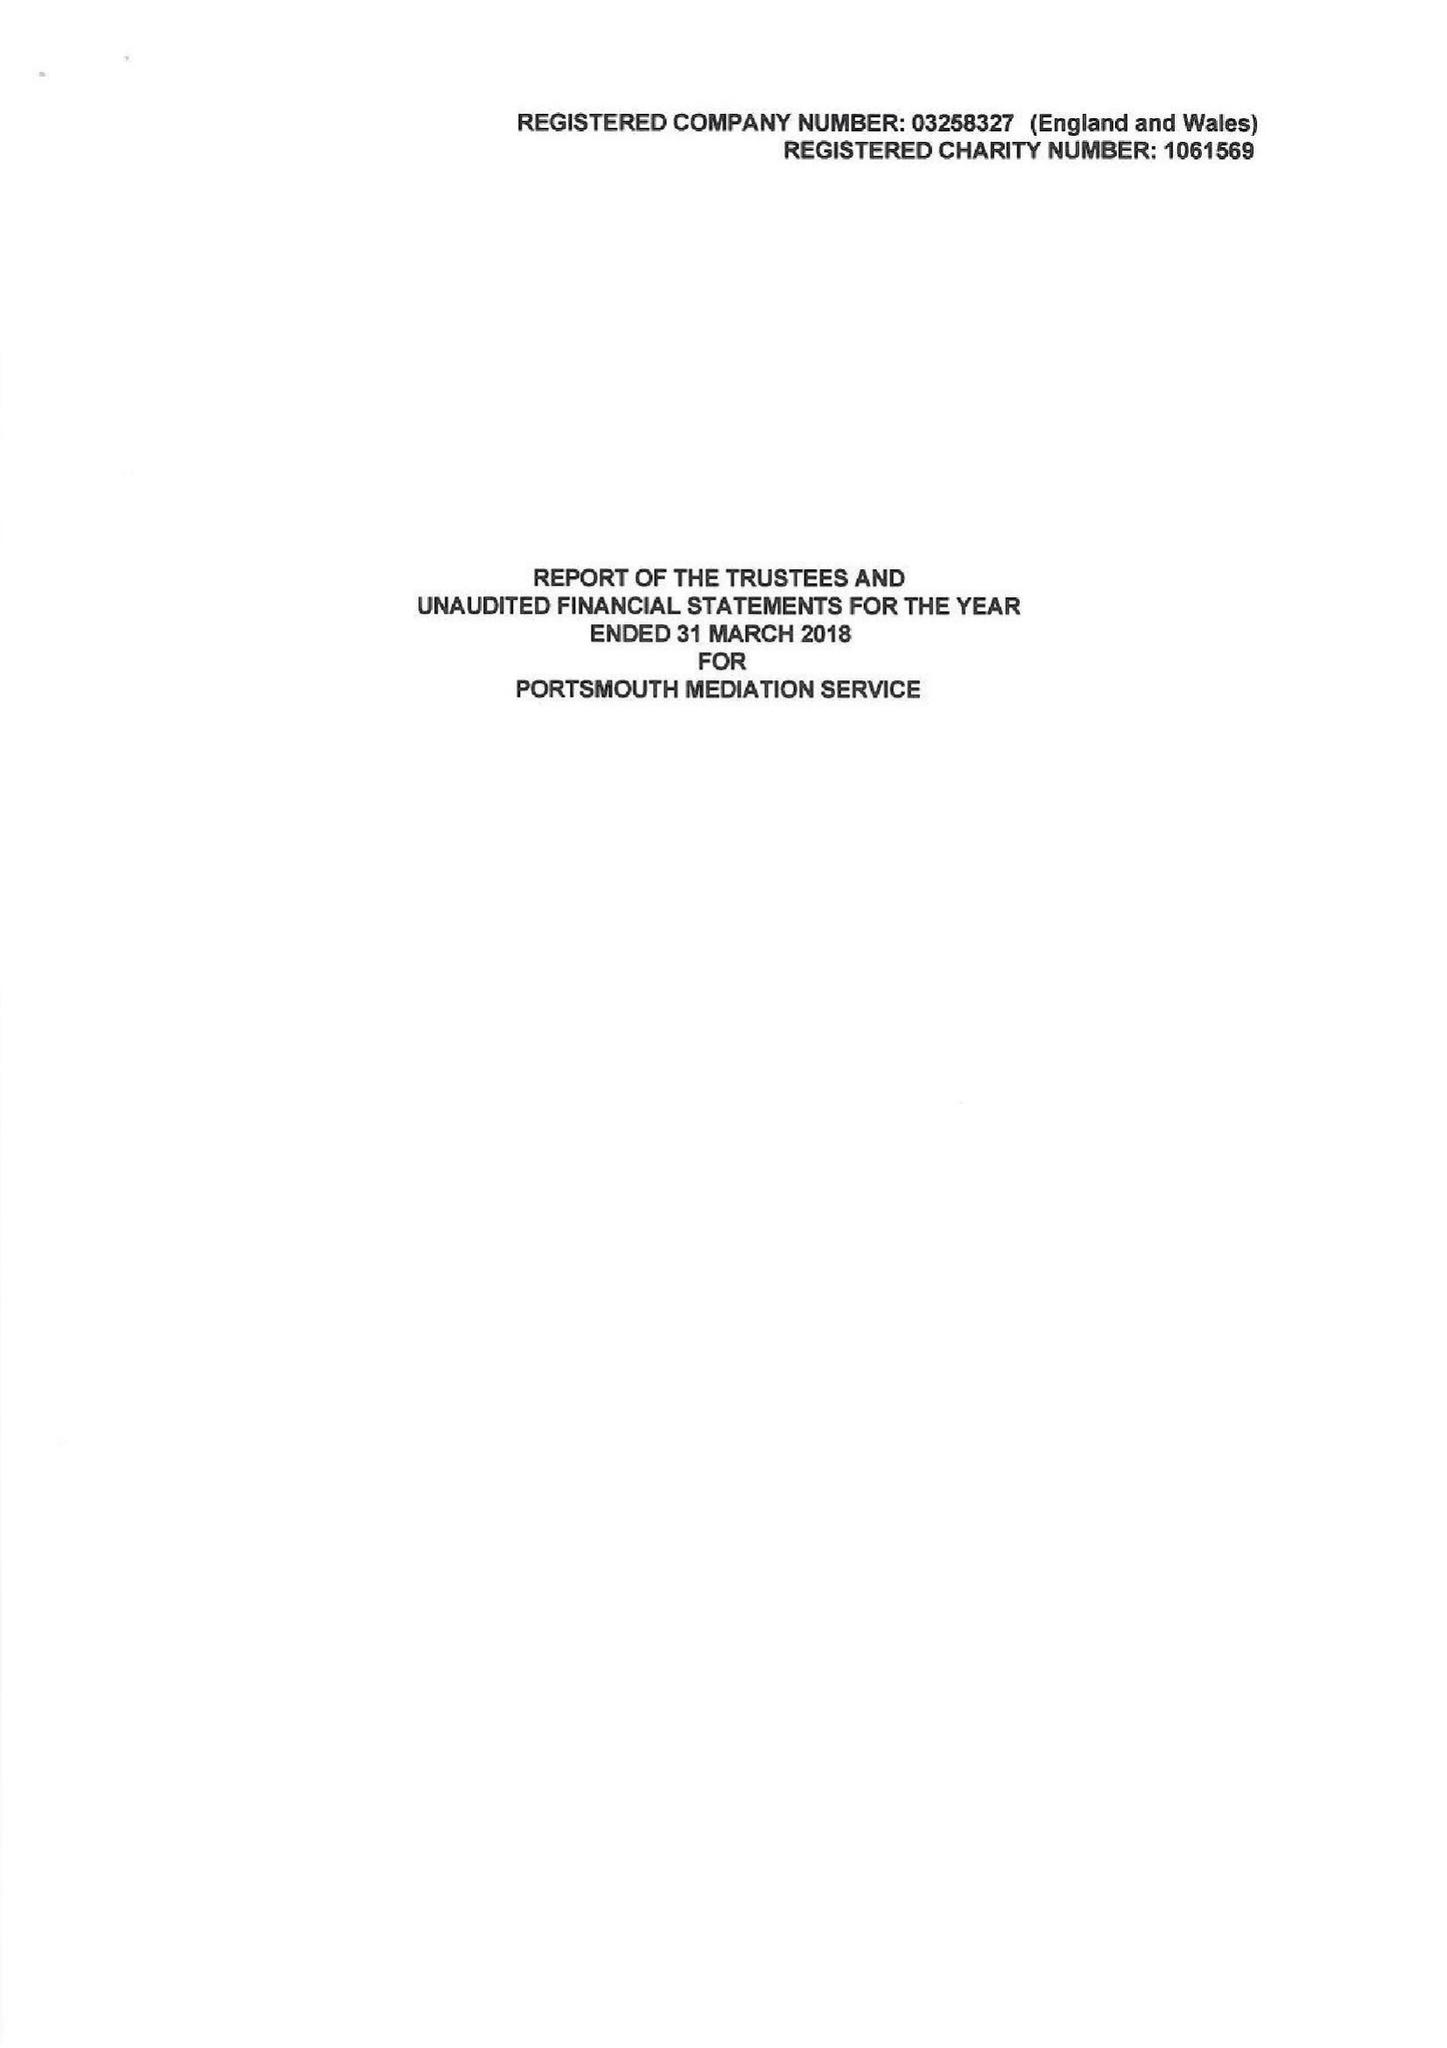What is the value for the charity_name?
Answer the question using a single word or phrase. Portsmouth Mediation Service 